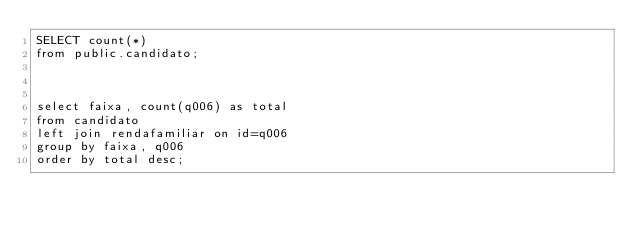Convert code to text. <code><loc_0><loc_0><loc_500><loc_500><_SQL_>SELECT count(*)
from public.candidato;



select faixa, count(q006) as total
from candidato
left join rendafamiliar on id=q006
group by faixa, q006
order by total desc;</code> 